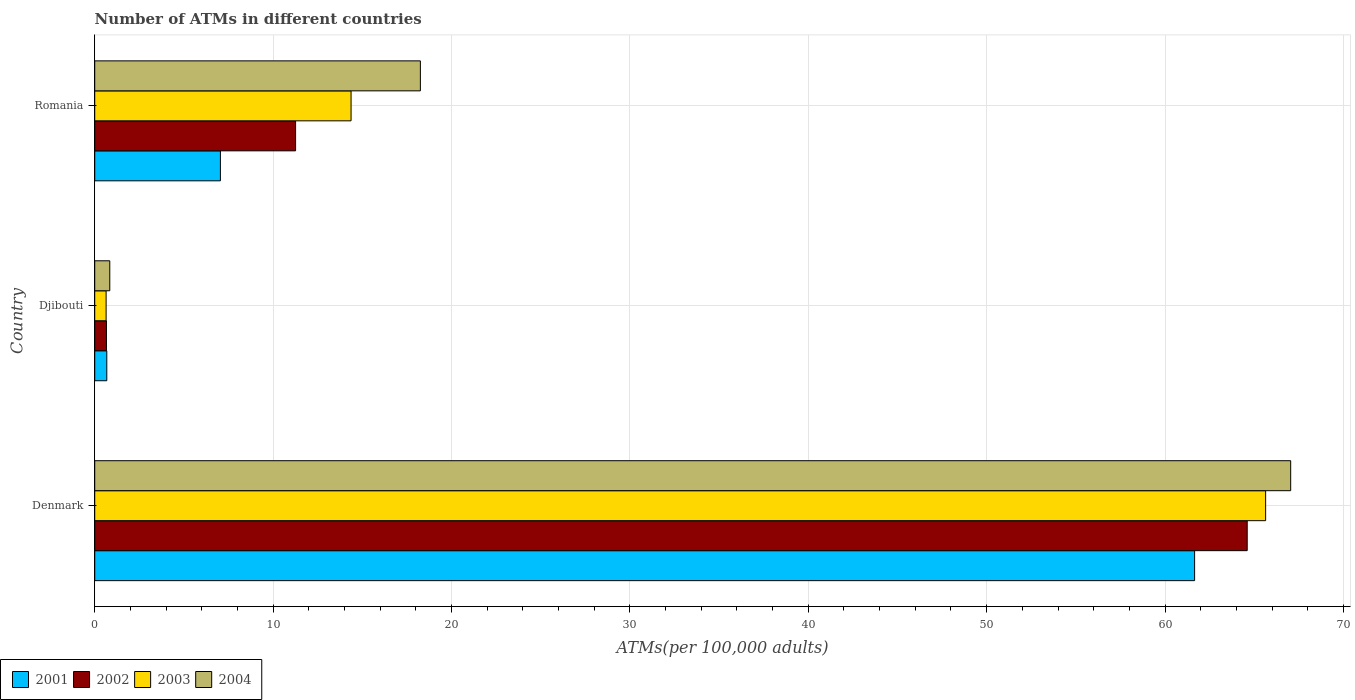How many different coloured bars are there?
Make the answer very short. 4. How many groups of bars are there?
Provide a succinct answer. 3. Are the number of bars on each tick of the Y-axis equal?
Provide a short and direct response. Yes. How many bars are there on the 3rd tick from the bottom?
Your response must be concise. 4. What is the label of the 2nd group of bars from the top?
Keep it short and to the point. Djibouti. What is the number of ATMs in 2003 in Romania?
Your answer should be very brief. 14.37. Across all countries, what is the maximum number of ATMs in 2002?
Your response must be concise. 64.61. Across all countries, what is the minimum number of ATMs in 2002?
Offer a terse response. 0.66. In which country was the number of ATMs in 2004 minimum?
Make the answer very short. Djibouti. What is the total number of ATMs in 2003 in the graph?
Make the answer very short. 80.65. What is the difference between the number of ATMs in 2003 in Djibouti and that in Romania?
Your answer should be compact. -13.73. What is the difference between the number of ATMs in 2002 in Romania and the number of ATMs in 2001 in Djibouti?
Ensure brevity in your answer.  10.58. What is the average number of ATMs in 2003 per country?
Provide a short and direct response. 26.88. What is the difference between the number of ATMs in 2001 and number of ATMs in 2003 in Romania?
Your answer should be compact. -7.32. In how many countries, is the number of ATMs in 2004 greater than 48 ?
Give a very brief answer. 1. What is the ratio of the number of ATMs in 2002 in Denmark to that in Romania?
Your answer should be very brief. 5.74. Is the number of ATMs in 2002 in Denmark less than that in Djibouti?
Keep it short and to the point. No. Is the difference between the number of ATMs in 2001 in Djibouti and Romania greater than the difference between the number of ATMs in 2003 in Djibouti and Romania?
Your answer should be very brief. Yes. What is the difference between the highest and the second highest number of ATMs in 2004?
Your answer should be very brief. 48.79. What is the difference between the highest and the lowest number of ATMs in 2002?
Offer a terse response. 63.95. Is it the case that in every country, the sum of the number of ATMs in 2001 and number of ATMs in 2002 is greater than the sum of number of ATMs in 2004 and number of ATMs in 2003?
Your response must be concise. No. What does the 1st bar from the top in Djibouti represents?
Your response must be concise. 2004. How many bars are there?
Provide a succinct answer. 12. How many countries are there in the graph?
Give a very brief answer. 3. What is the difference between two consecutive major ticks on the X-axis?
Give a very brief answer. 10. Are the values on the major ticks of X-axis written in scientific E-notation?
Provide a succinct answer. No. Does the graph contain any zero values?
Offer a terse response. No. Does the graph contain grids?
Offer a very short reply. Yes. What is the title of the graph?
Make the answer very short. Number of ATMs in different countries. What is the label or title of the X-axis?
Give a very brief answer. ATMs(per 100,0 adults). What is the label or title of the Y-axis?
Offer a very short reply. Country. What is the ATMs(per 100,000 adults) in 2001 in Denmark?
Your answer should be compact. 61.66. What is the ATMs(per 100,000 adults) in 2002 in Denmark?
Your response must be concise. 64.61. What is the ATMs(per 100,000 adults) of 2003 in Denmark?
Provide a short and direct response. 65.64. What is the ATMs(per 100,000 adults) in 2004 in Denmark?
Provide a succinct answer. 67.04. What is the ATMs(per 100,000 adults) in 2001 in Djibouti?
Ensure brevity in your answer.  0.68. What is the ATMs(per 100,000 adults) in 2002 in Djibouti?
Make the answer very short. 0.66. What is the ATMs(per 100,000 adults) of 2003 in Djibouti?
Your response must be concise. 0.64. What is the ATMs(per 100,000 adults) of 2004 in Djibouti?
Provide a succinct answer. 0.84. What is the ATMs(per 100,000 adults) in 2001 in Romania?
Offer a very short reply. 7.04. What is the ATMs(per 100,000 adults) of 2002 in Romania?
Keep it short and to the point. 11.26. What is the ATMs(per 100,000 adults) in 2003 in Romania?
Make the answer very short. 14.37. What is the ATMs(per 100,000 adults) in 2004 in Romania?
Keep it short and to the point. 18.26. Across all countries, what is the maximum ATMs(per 100,000 adults) of 2001?
Ensure brevity in your answer.  61.66. Across all countries, what is the maximum ATMs(per 100,000 adults) of 2002?
Provide a short and direct response. 64.61. Across all countries, what is the maximum ATMs(per 100,000 adults) of 2003?
Make the answer very short. 65.64. Across all countries, what is the maximum ATMs(per 100,000 adults) in 2004?
Offer a very short reply. 67.04. Across all countries, what is the minimum ATMs(per 100,000 adults) in 2001?
Your answer should be very brief. 0.68. Across all countries, what is the minimum ATMs(per 100,000 adults) in 2002?
Make the answer very short. 0.66. Across all countries, what is the minimum ATMs(per 100,000 adults) of 2003?
Your answer should be very brief. 0.64. Across all countries, what is the minimum ATMs(per 100,000 adults) of 2004?
Provide a short and direct response. 0.84. What is the total ATMs(per 100,000 adults) of 2001 in the graph?
Your answer should be very brief. 69.38. What is the total ATMs(per 100,000 adults) in 2002 in the graph?
Make the answer very short. 76.52. What is the total ATMs(per 100,000 adults) of 2003 in the graph?
Provide a short and direct response. 80.65. What is the total ATMs(per 100,000 adults) in 2004 in the graph?
Provide a short and direct response. 86.14. What is the difference between the ATMs(per 100,000 adults) in 2001 in Denmark and that in Djibouti?
Your answer should be compact. 60.98. What is the difference between the ATMs(per 100,000 adults) in 2002 in Denmark and that in Djibouti?
Your answer should be compact. 63.95. What is the difference between the ATMs(per 100,000 adults) of 2003 in Denmark and that in Djibouti?
Offer a terse response. 65. What is the difference between the ATMs(per 100,000 adults) of 2004 in Denmark and that in Djibouti?
Your answer should be compact. 66.2. What is the difference between the ATMs(per 100,000 adults) in 2001 in Denmark and that in Romania?
Provide a short and direct response. 54.61. What is the difference between the ATMs(per 100,000 adults) in 2002 in Denmark and that in Romania?
Your answer should be very brief. 53.35. What is the difference between the ATMs(per 100,000 adults) in 2003 in Denmark and that in Romania?
Offer a very short reply. 51.27. What is the difference between the ATMs(per 100,000 adults) in 2004 in Denmark and that in Romania?
Your response must be concise. 48.79. What is the difference between the ATMs(per 100,000 adults) in 2001 in Djibouti and that in Romania?
Your answer should be very brief. -6.37. What is the difference between the ATMs(per 100,000 adults) in 2002 in Djibouti and that in Romania?
Offer a very short reply. -10.6. What is the difference between the ATMs(per 100,000 adults) in 2003 in Djibouti and that in Romania?
Your response must be concise. -13.73. What is the difference between the ATMs(per 100,000 adults) of 2004 in Djibouti and that in Romania?
Your response must be concise. -17.41. What is the difference between the ATMs(per 100,000 adults) in 2001 in Denmark and the ATMs(per 100,000 adults) in 2002 in Djibouti?
Keep it short and to the point. 61. What is the difference between the ATMs(per 100,000 adults) of 2001 in Denmark and the ATMs(per 100,000 adults) of 2003 in Djibouti?
Offer a terse response. 61.02. What is the difference between the ATMs(per 100,000 adults) of 2001 in Denmark and the ATMs(per 100,000 adults) of 2004 in Djibouti?
Offer a very short reply. 60.81. What is the difference between the ATMs(per 100,000 adults) of 2002 in Denmark and the ATMs(per 100,000 adults) of 2003 in Djibouti?
Make the answer very short. 63.97. What is the difference between the ATMs(per 100,000 adults) in 2002 in Denmark and the ATMs(per 100,000 adults) in 2004 in Djibouti?
Provide a short and direct response. 63.76. What is the difference between the ATMs(per 100,000 adults) of 2003 in Denmark and the ATMs(per 100,000 adults) of 2004 in Djibouti?
Make the answer very short. 64.79. What is the difference between the ATMs(per 100,000 adults) of 2001 in Denmark and the ATMs(per 100,000 adults) of 2002 in Romania?
Make the answer very short. 50.4. What is the difference between the ATMs(per 100,000 adults) in 2001 in Denmark and the ATMs(per 100,000 adults) in 2003 in Romania?
Provide a short and direct response. 47.29. What is the difference between the ATMs(per 100,000 adults) in 2001 in Denmark and the ATMs(per 100,000 adults) in 2004 in Romania?
Offer a terse response. 43.4. What is the difference between the ATMs(per 100,000 adults) of 2002 in Denmark and the ATMs(per 100,000 adults) of 2003 in Romania?
Provide a short and direct response. 50.24. What is the difference between the ATMs(per 100,000 adults) in 2002 in Denmark and the ATMs(per 100,000 adults) in 2004 in Romania?
Keep it short and to the point. 46.35. What is the difference between the ATMs(per 100,000 adults) in 2003 in Denmark and the ATMs(per 100,000 adults) in 2004 in Romania?
Ensure brevity in your answer.  47.38. What is the difference between the ATMs(per 100,000 adults) of 2001 in Djibouti and the ATMs(per 100,000 adults) of 2002 in Romania?
Your answer should be very brief. -10.58. What is the difference between the ATMs(per 100,000 adults) in 2001 in Djibouti and the ATMs(per 100,000 adults) in 2003 in Romania?
Your response must be concise. -13.69. What is the difference between the ATMs(per 100,000 adults) of 2001 in Djibouti and the ATMs(per 100,000 adults) of 2004 in Romania?
Your answer should be compact. -17.58. What is the difference between the ATMs(per 100,000 adults) of 2002 in Djibouti and the ATMs(per 100,000 adults) of 2003 in Romania?
Your response must be concise. -13.71. What is the difference between the ATMs(per 100,000 adults) in 2002 in Djibouti and the ATMs(per 100,000 adults) in 2004 in Romania?
Your answer should be compact. -17.6. What is the difference between the ATMs(per 100,000 adults) in 2003 in Djibouti and the ATMs(per 100,000 adults) in 2004 in Romania?
Your answer should be compact. -17.62. What is the average ATMs(per 100,000 adults) in 2001 per country?
Provide a succinct answer. 23.13. What is the average ATMs(per 100,000 adults) in 2002 per country?
Make the answer very short. 25.51. What is the average ATMs(per 100,000 adults) of 2003 per country?
Provide a succinct answer. 26.88. What is the average ATMs(per 100,000 adults) of 2004 per country?
Your answer should be very brief. 28.71. What is the difference between the ATMs(per 100,000 adults) in 2001 and ATMs(per 100,000 adults) in 2002 in Denmark?
Offer a terse response. -2.95. What is the difference between the ATMs(per 100,000 adults) in 2001 and ATMs(per 100,000 adults) in 2003 in Denmark?
Offer a very short reply. -3.98. What is the difference between the ATMs(per 100,000 adults) of 2001 and ATMs(per 100,000 adults) of 2004 in Denmark?
Give a very brief answer. -5.39. What is the difference between the ATMs(per 100,000 adults) of 2002 and ATMs(per 100,000 adults) of 2003 in Denmark?
Your response must be concise. -1.03. What is the difference between the ATMs(per 100,000 adults) in 2002 and ATMs(per 100,000 adults) in 2004 in Denmark?
Your answer should be very brief. -2.44. What is the difference between the ATMs(per 100,000 adults) in 2003 and ATMs(per 100,000 adults) in 2004 in Denmark?
Give a very brief answer. -1.41. What is the difference between the ATMs(per 100,000 adults) in 2001 and ATMs(per 100,000 adults) in 2002 in Djibouti?
Give a very brief answer. 0.02. What is the difference between the ATMs(per 100,000 adults) in 2001 and ATMs(per 100,000 adults) in 2003 in Djibouti?
Your answer should be compact. 0.04. What is the difference between the ATMs(per 100,000 adults) of 2001 and ATMs(per 100,000 adults) of 2004 in Djibouti?
Your answer should be very brief. -0.17. What is the difference between the ATMs(per 100,000 adults) of 2002 and ATMs(per 100,000 adults) of 2003 in Djibouti?
Provide a succinct answer. 0.02. What is the difference between the ATMs(per 100,000 adults) in 2002 and ATMs(per 100,000 adults) in 2004 in Djibouti?
Ensure brevity in your answer.  -0.19. What is the difference between the ATMs(per 100,000 adults) of 2003 and ATMs(per 100,000 adults) of 2004 in Djibouti?
Make the answer very short. -0.21. What is the difference between the ATMs(per 100,000 adults) in 2001 and ATMs(per 100,000 adults) in 2002 in Romania?
Your response must be concise. -4.21. What is the difference between the ATMs(per 100,000 adults) in 2001 and ATMs(per 100,000 adults) in 2003 in Romania?
Your response must be concise. -7.32. What is the difference between the ATMs(per 100,000 adults) in 2001 and ATMs(per 100,000 adults) in 2004 in Romania?
Provide a short and direct response. -11.21. What is the difference between the ATMs(per 100,000 adults) of 2002 and ATMs(per 100,000 adults) of 2003 in Romania?
Offer a very short reply. -3.11. What is the difference between the ATMs(per 100,000 adults) of 2002 and ATMs(per 100,000 adults) of 2004 in Romania?
Provide a succinct answer. -7. What is the difference between the ATMs(per 100,000 adults) in 2003 and ATMs(per 100,000 adults) in 2004 in Romania?
Give a very brief answer. -3.89. What is the ratio of the ATMs(per 100,000 adults) of 2001 in Denmark to that in Djibouti?
Offer a very short reply. 91.18. What is the ratio of the ATMs(per 100,000 adults) of 2002 in Denmark to that in Djibouti?
Ensure brevity in your answer.  98.45. What is the ratio of the ATMs(per 100,000 adults) of 2003 in Denmark to that in Djibouti?
Offer a terse response. 102.88. What is the ratio of the ATMs(per 100,000 adults) in 2004 in Denmark to that in Djibouti?
Provide a short and direct response. 79.46. What is the ratio of the ATMs(per 100,000 adults) of 2001 in Denmark to that in Romania?
Your answer should be very brief. 8.75. What is the ratio of the ATMs(per 100,000 adults) of 2002 in Denmark to that in Romania?
Ensure brevity in your answer.  5.74. What is the ratio of the ATMs(per 100,000 adults) of 2003 in Denmark to that in Romania?
Provide a short and direct response. 4.57. What is the ratio of the ATMs(per 100,000 adults) of 2004 in Denmark to that in Romania?
Make the answer very short. 3.67. What is the ratio of the ATMs(per 100,000 adults) in 2001 in Djibouti to that in Romania?
Your answer should be very brief. 0.1. What is the ratio of the ATMs(per 100,000 adults) of 2002 in Djibouti to that in Romania?
Your response must be concise. 0.06. What is the ratio of the ATMs(per 100,000 adults) in 2003 in Djibouti to that in Romania?
Make the answer very short. 0.04. What is the ratio of the ATMs(per 100,000 adults) of 2004 in Djibouti to that in Romania?
Keep it short and to the point. 0.05. What is the difference between the highest and the second highest ATMs(per 100,000 adults) of 2001?
Offer a terse response. 54.61. What is the difference between the highest and the second highest ATMs(per 100,000 adults) in 2002?
Provide a succinct answer. 53.35. What is the difference between the highest and the second highest ATMs(per 100,000 adults) in 2003?
Make the answer very short. 51.27. What is the difference between the highest and the second highest ATMs(per 100,000 adults) in 2004?
Provide a succinct answer. 48.79. What is the difference between the highest and the lowest ATMs(per 100,000 adults) in 2001?
Provide a short and direct response. 60.98. What is the difference between the highest and the lowest ATMs(per 100,000 adults) of 2002?
Offer a terse response. 63.95. What is the difference between the highest and the lowest ATMs(per 100,000 adults) of 2003?
Your answer should be compact. 65. What is the difference between the highest and the lowest ATMs(per 100,000 adults) of 2004?
Make the answer very short. 66.2. 